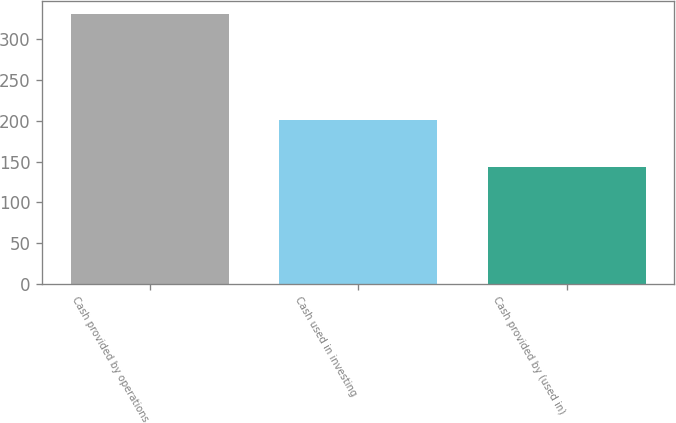Convert chart to OTSL. <chart><loc_0><loc_0><loc_500><loc_500><bar_chart><fcel>Cash provided by operations<fcel>Cash used in investing<fcel>Cash provided by (used in)<nl><fcel>331.1<fcel>201.1<fcel>143.8<nl></chart> 